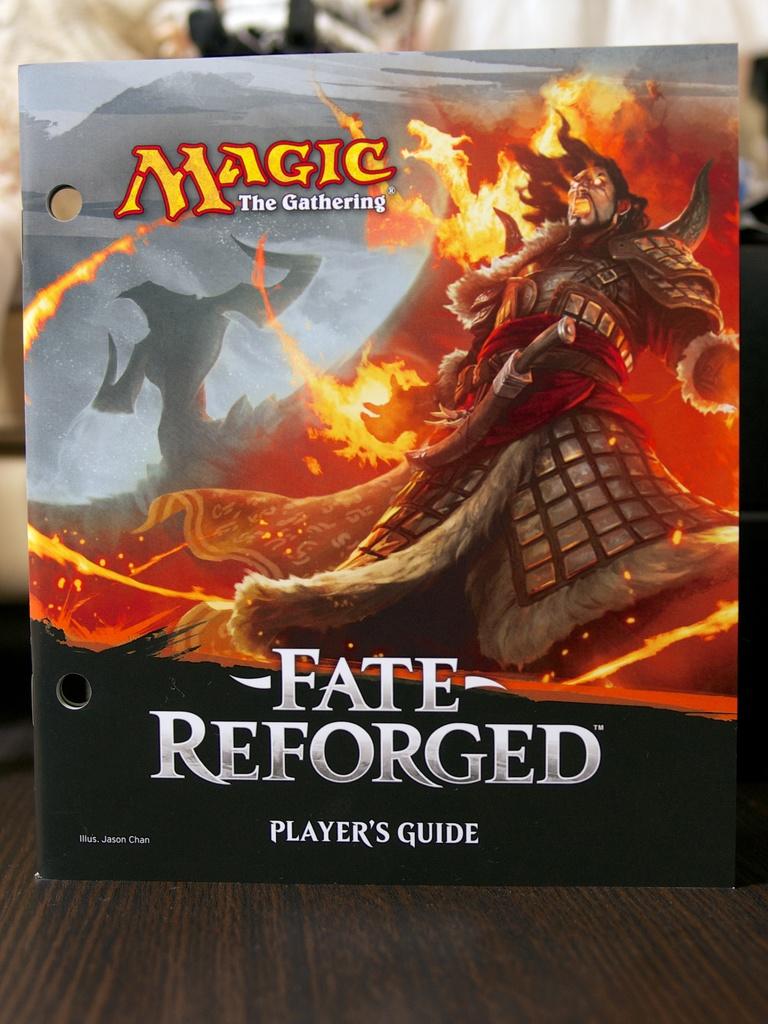What is the title of this guide called?
Offer a very short reply. Fate reforged. 